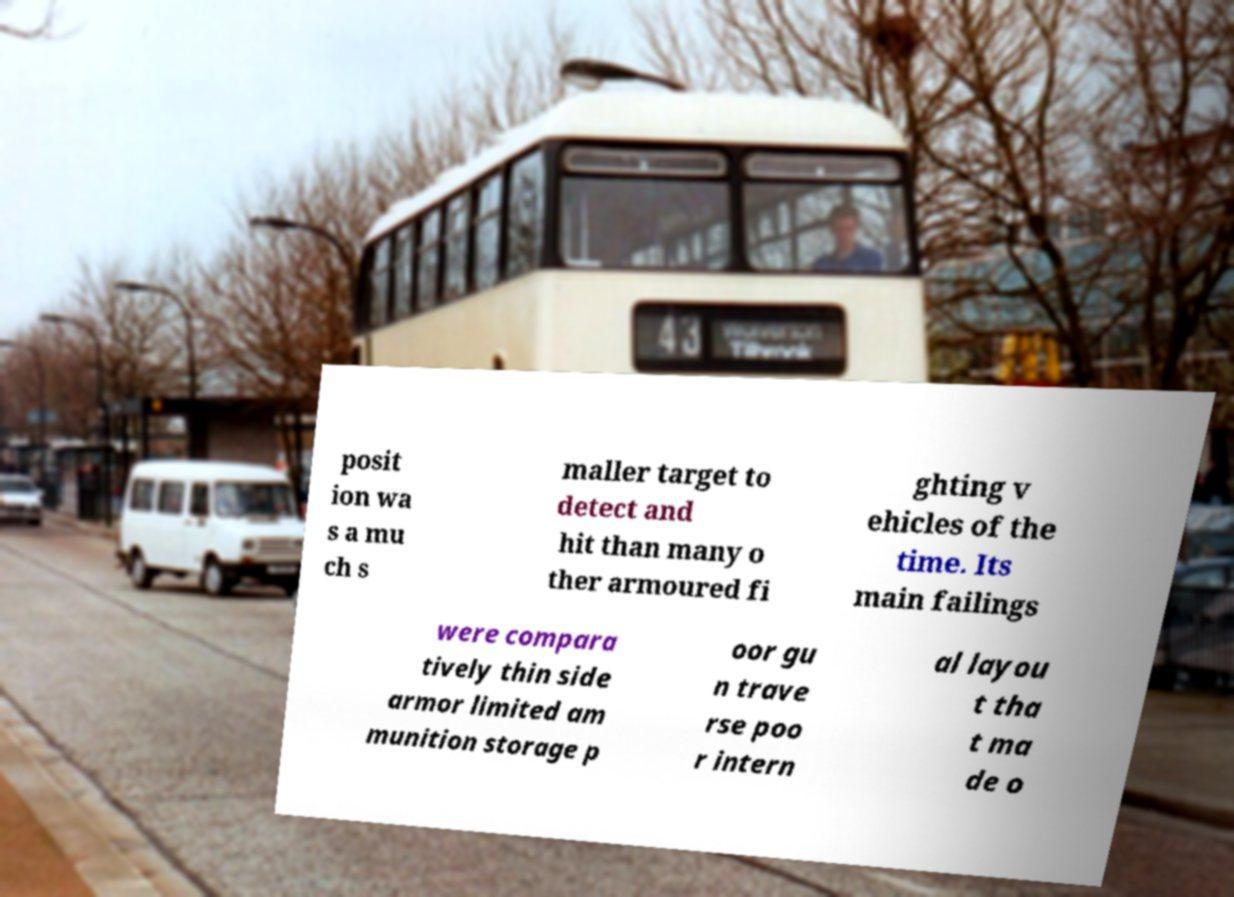I need the written content from this picture converted into text. Can you do that? posit ion wa s a mu ch s maller target to detect and hit than many o ther armoured fi ghting v ehicles of the time. Its main failings were compara tively thin side armor limited am munition storage p oor gu n trave rse poo r intern al layou t tha t ma de o 